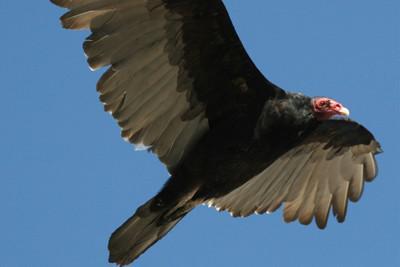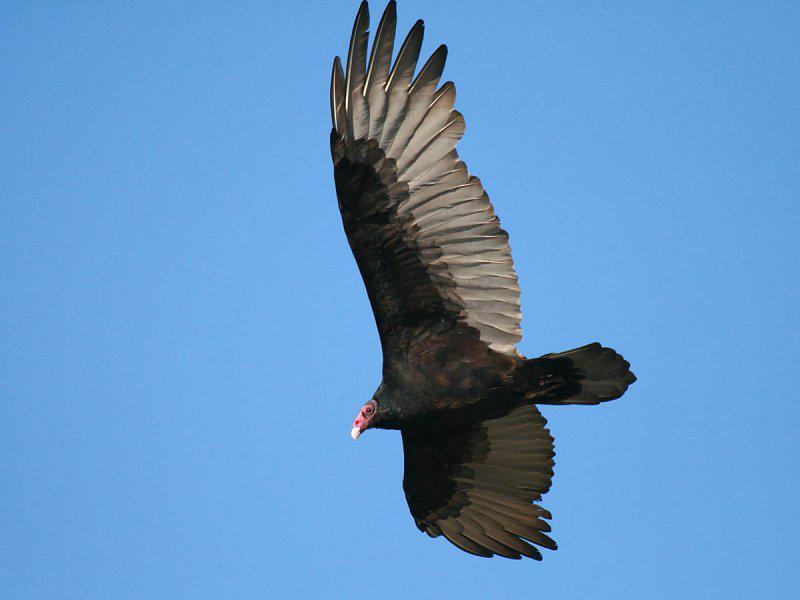The first image is the image on the left, the second image is the image on the right. Considering the images on both sides, is "All of the birds are flying." valid? Answer yes or no. Yes. The first image is the image on the left, the second image is the image on the right. Assess this claim about the two images: "The bird on the right image is facing right.". Correct or not? Answer yes or no. No. 